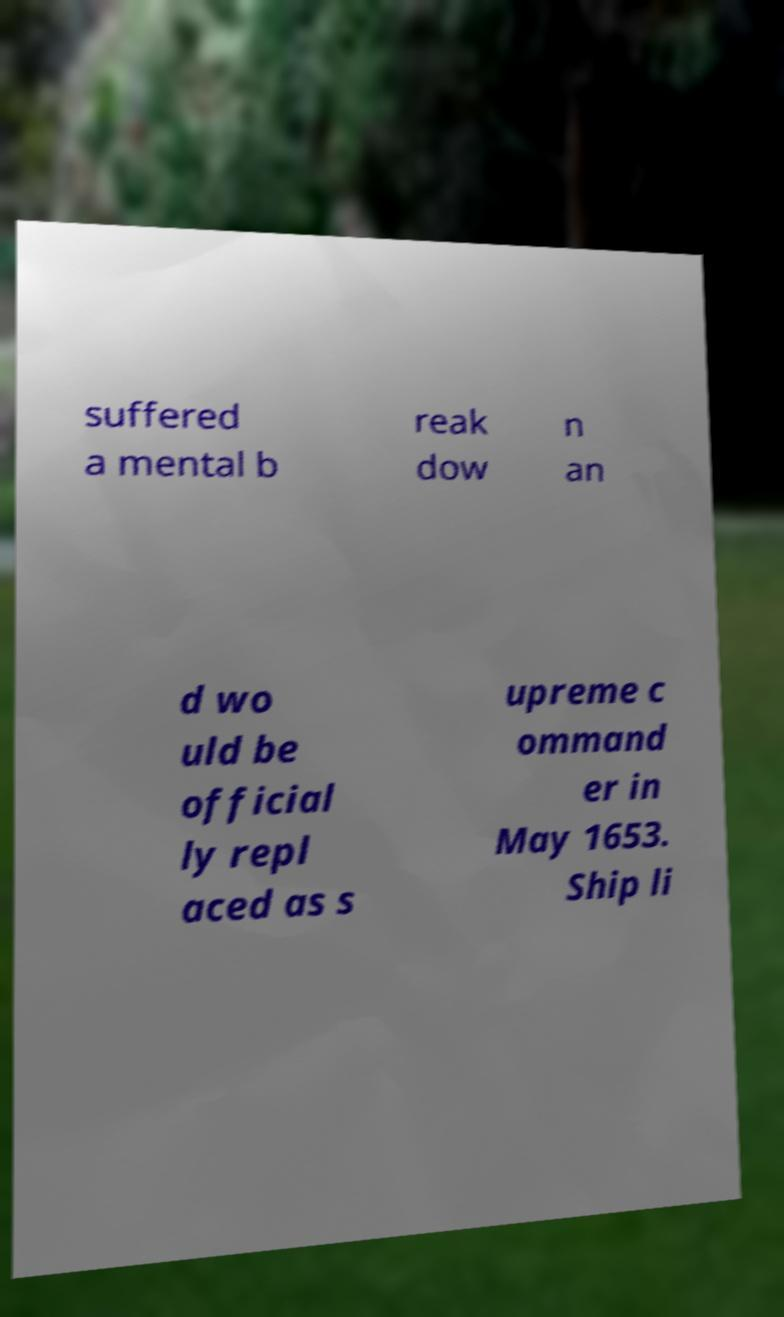I need the written content from this picture converted into text. Can you do that? suffered a mental b reak dow n an d wo uld be official ly repl aced as s upreme c ommand er in May 1653. Ship li 